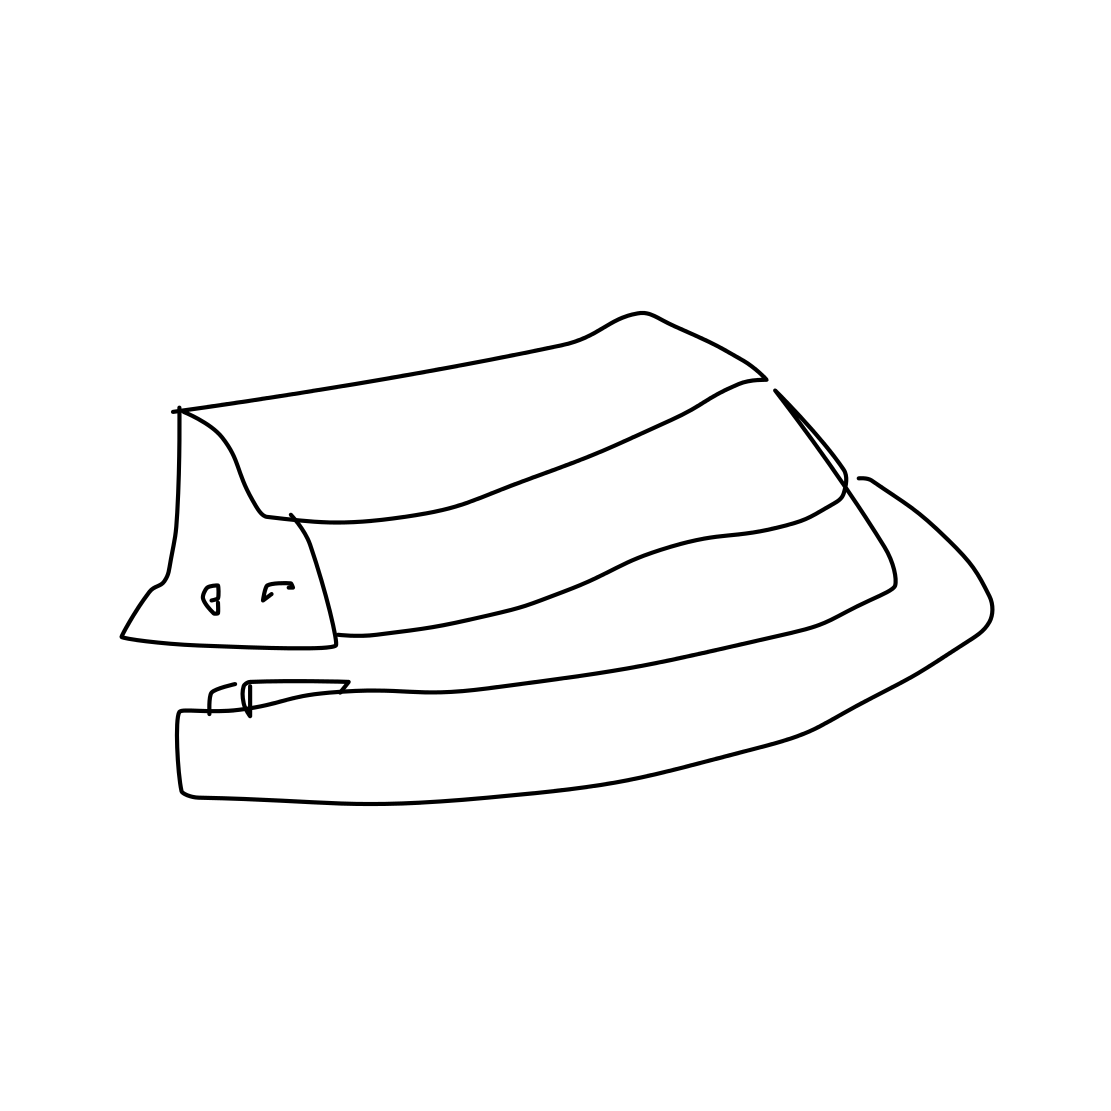Is this a book in the image? The image depicts a drawing of a piece of clothing, specifically a hat, rather than a book. It's characterized by its brim and a visible band, typical features of hats. 